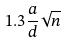<formula> <loc_0><loc_0><loc_500><loc_500>1 . 3 \frac { a } { d } \sqrt { n }</formula> 